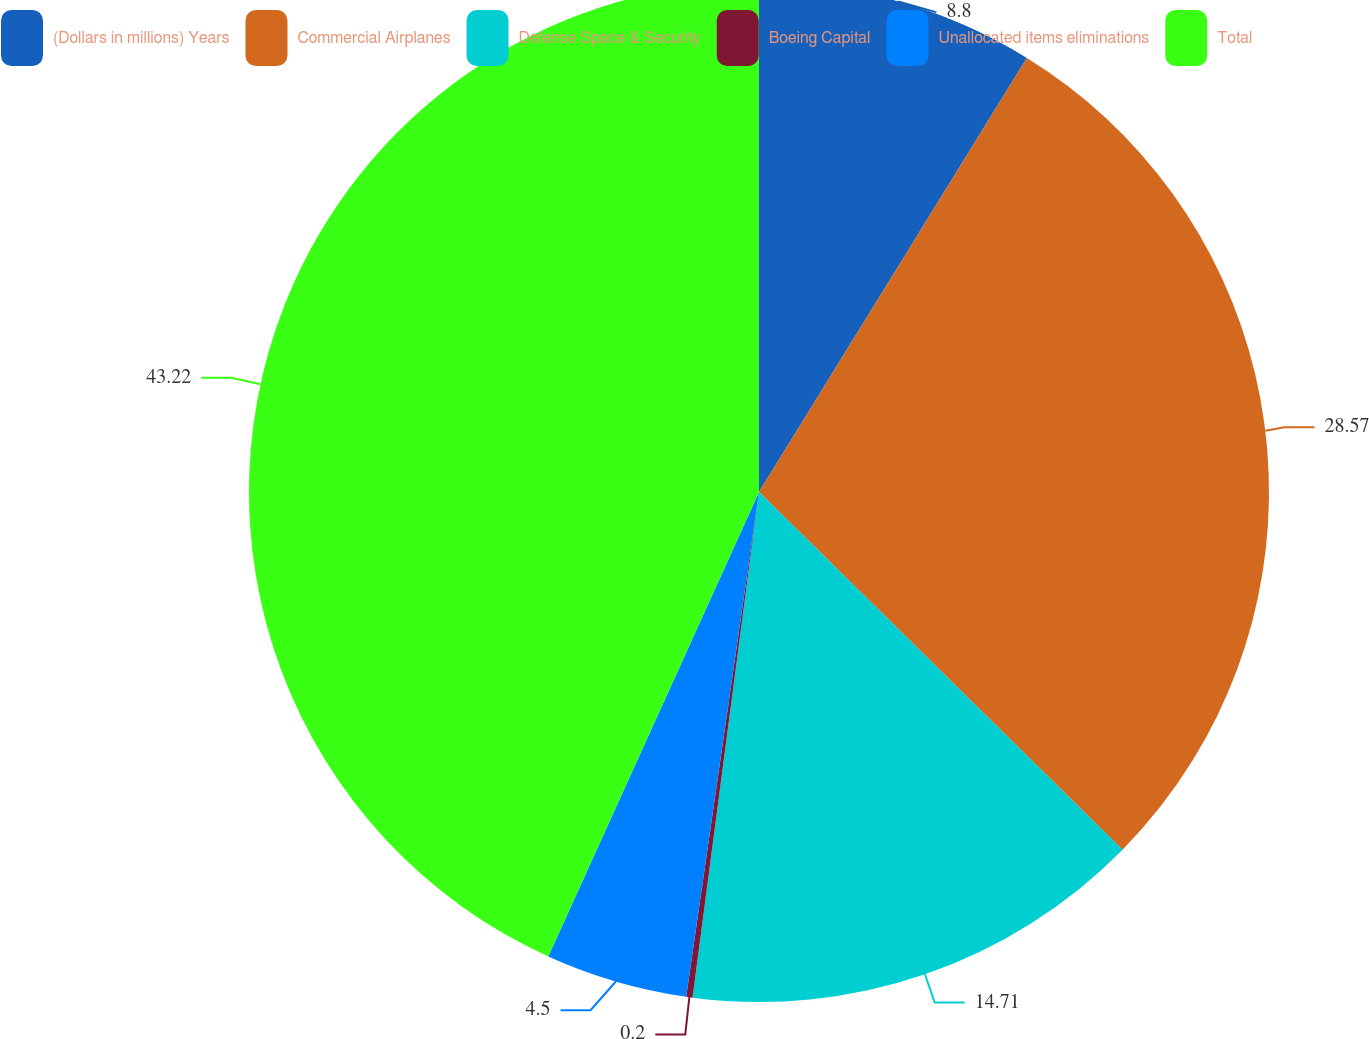<chart> <loc_0><loc_0><loc_500><loc_500><pie_chart><fcel>(Dollars in millions) Years<fcel>Commercial Airplanes<fcel>Defense Space & Security<fcel>Boeing Capital<fcel>Unallocated items eliminations<fcel>Total<nl><fcel>8.8%<fcel>28.57%<fcel>14.71%<fcel>0.2%<fcel>4.5%<fcel>43.22%<nl></chart> 